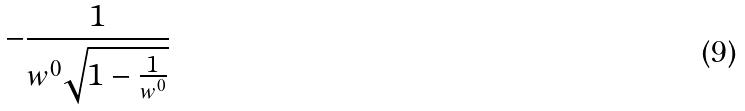<formula> <loc_0><loc_0><loc_500><loc_500>- \frac { 1 } { w ^ { 0 } \sqrt { 1 - \frac { 1 } { w ^ { 0 } } } }</formula> 